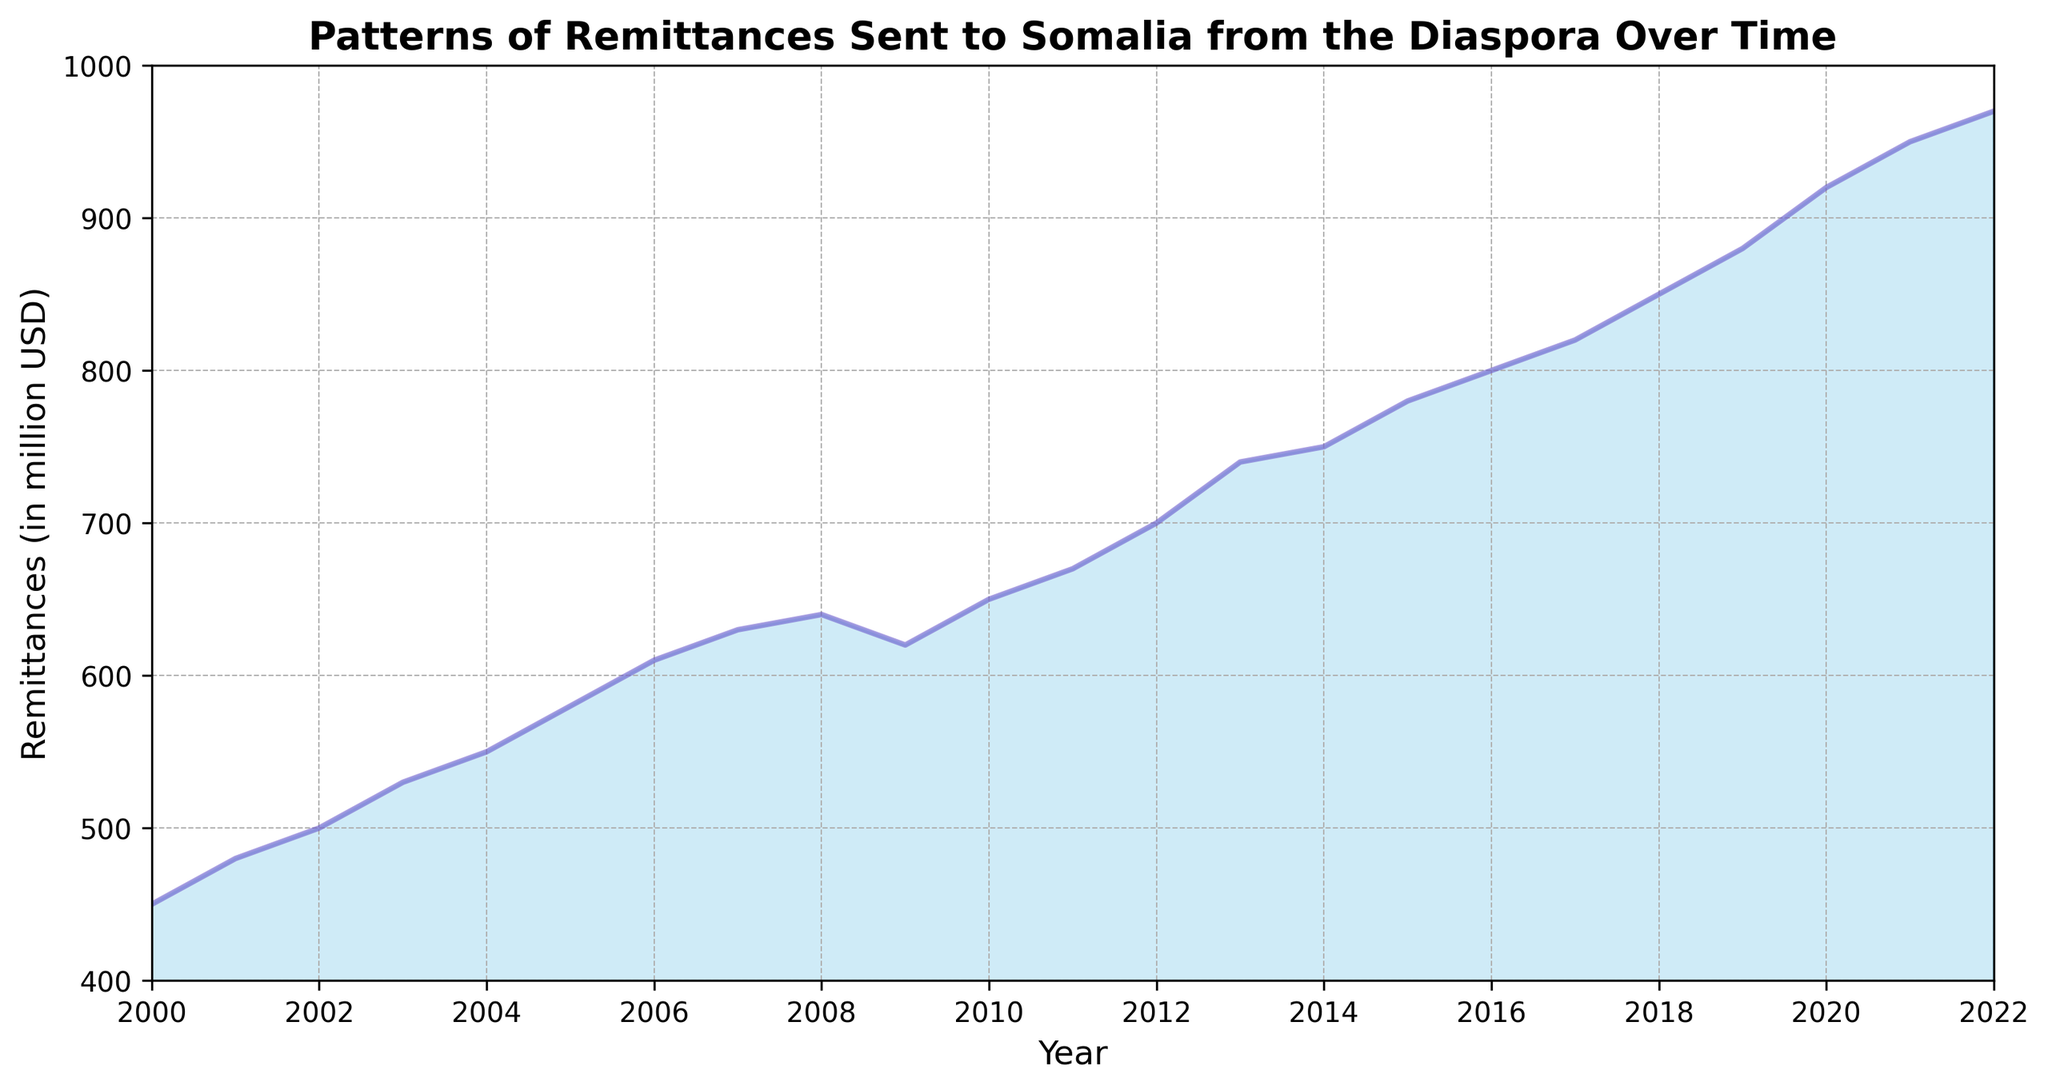What's the trend in remittances to Somalia from 2000 to 2022? To find the trend, we analyze the pattern of the area chart from 2000 to 2022. The graph shows a generally increasing pattern in the remittances sent to Somalia with minor fluctuations. The remittances start at 450 million USD in 2000 and rise to 970 million USD by 2022.
Answer: Increasing Which year saw the smallest increase in remittances over the previous year? To determine the smallest increase, we compare the differences between consecutive years. The smallest increase is between 2008 (640M) and 2009 (620M) where there is actually a decrease in remittances.
Answer: 2009 In which year did remittances experience the largest single-year increase? We calculate the difference in remittances between each consecutive year and find the highest value. The largest increase is from 2008 (640M) to 2009 (620M), though it's a decrease. For positive increases, 2018 to 2019 saw an increase from 850 million USD to 880 million USD.
Answer: 2018-2019 What is the average remittance amount from 2000 to 2022? To find the average, sum all the remittance amounts from 2000 to 2022 and divide by the number of years: (450 + 480 + ... + 970) / 23 = 708.26 million USD
Answer: 708.26 million USD How do the remittances in 2010 compare to those in 2005? Compare the remittance amounts for the two years directly from the chart. In 2005, remittances were 580 million USD, and in 2010, they were 650 million USD. So, remittances in 2010 are 70 million USD higher than in 2005.
Answer: 70 million USD higher Between which consecutive years did remittances first surpass 700 million USD? Analyze the chart and identify the first year remittances exceed 700 million USD. It occurs between 2011 (670M) and 2012 (700M).
Answer: 2011-2012 Identify the period with the most significant upward trend in remittances. Examine the steepness of the plots in the chart to find the period with the steepest slope. The period from 2010 to 2015 shows consistent and significant increases, from around 650 million USD to 780 million USD.
Answer: 2010-2015 What is the total increase in remittances from 2000 to 2022? Calculate the difference between the remittance in 2022 and 2000: 970M - 450M = 520M USD increase.
Answer: 520 million USD During which five-year period did remittances grow the most? Compare the growth in five-year periods: 2000-2005, 2005-2010, 2010-2015, 2015-2020. The period 2015-2020 shows the highest increase: (920M - 780M) = 140 million USD.
Answer: 2015-2020 How do the remittances in 2021 compare to the average remittances over the entire period? The remittances in 2021 are 950M. Compare this to the average calculated previously (708.26M). 950M is significantly higher than the average.
Answer: Higher 